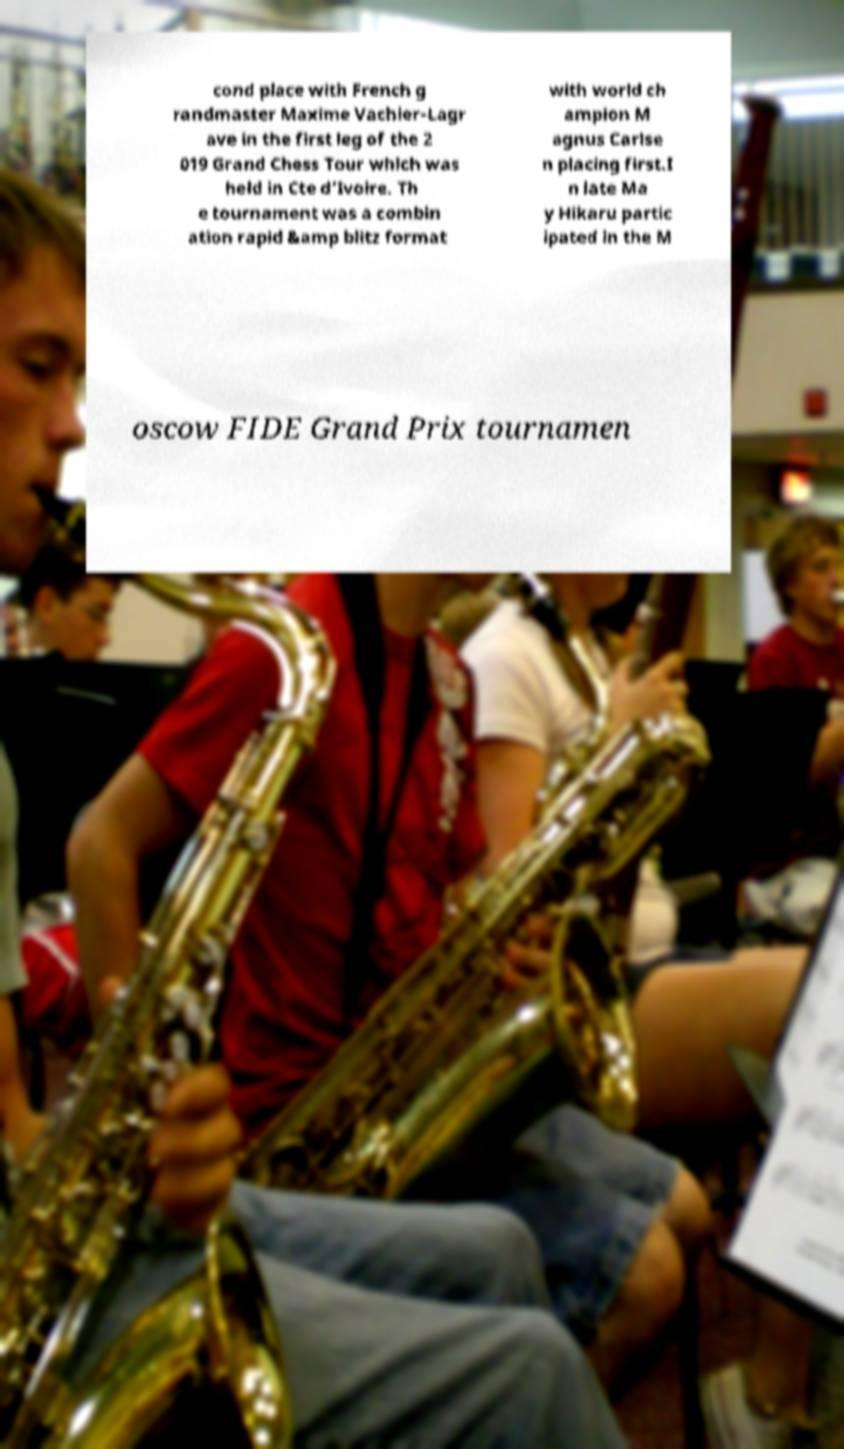Could you assist in decoding the text presented in this image and type it out clearly? cond place with French g randmaster Maxime Vachier-Lagr ave in the first leg of the 2 019 Grand Chess Tour which was held in Cte d’Ivoire. Th e tournament was a combin ation rapid &amp blitz format with world ch ampion M agnus Carlse n placing first.I n late Ma y Hikaru partic ipated in the M oscow FIDE Grand Prix tournamen 